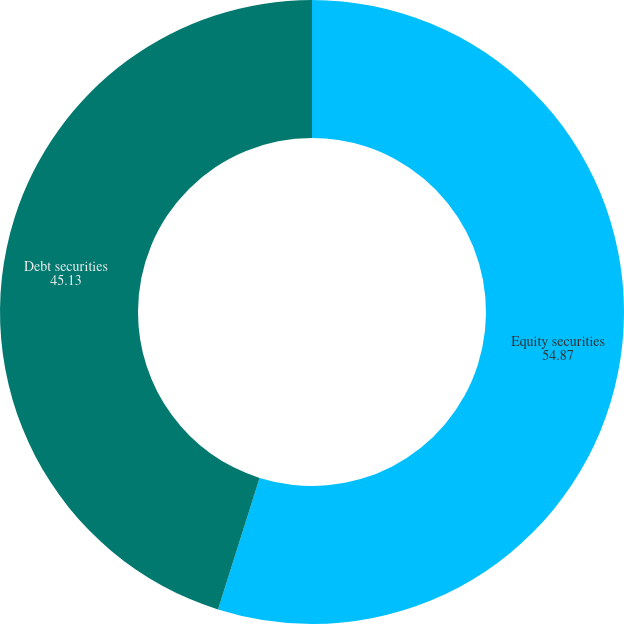Convert chart. <chart><loc_0><loc_0><loc_500><loc_500><pie_chart><fcel>Equity securities<fcel>Debt securities<nl><fcel>54.87%<fcel>45.13%<nl></chart> 